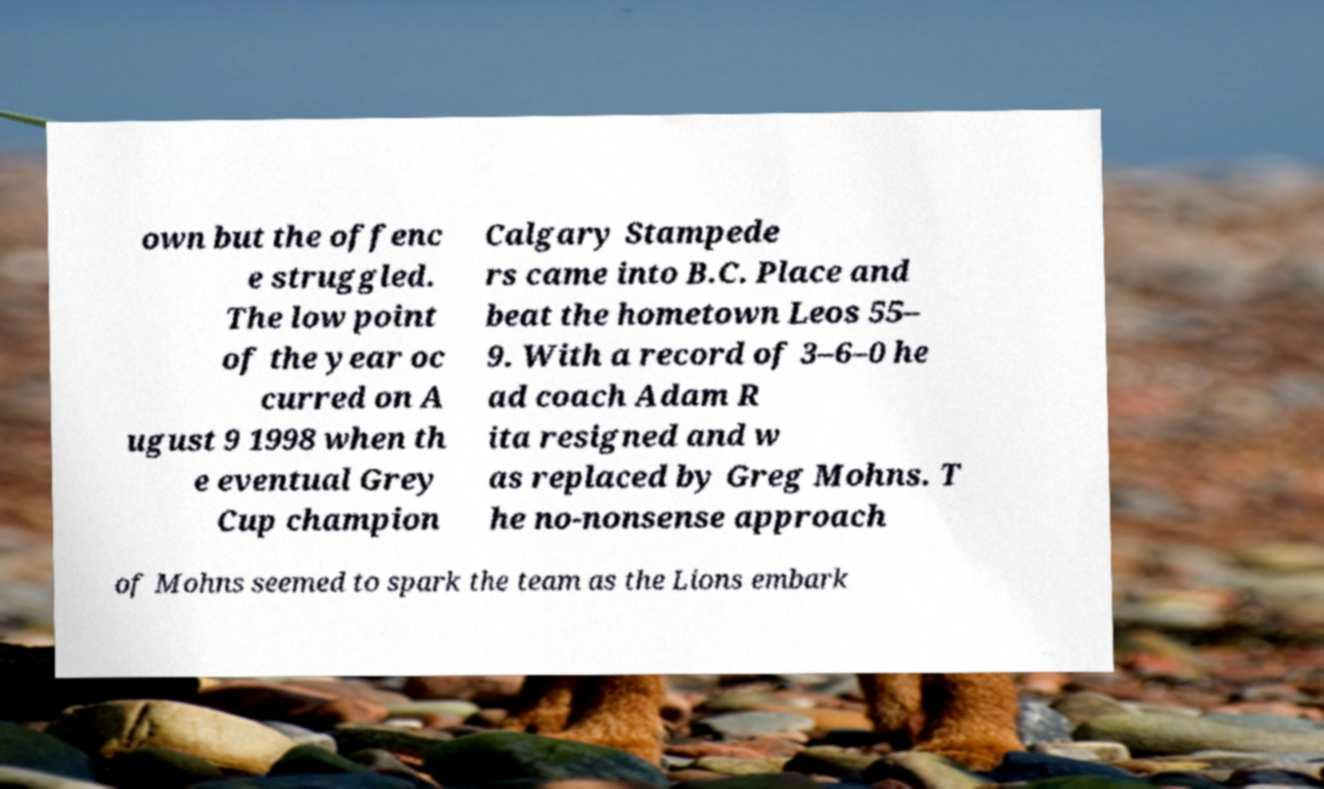Can you read and provide the text displayed in the image?This photo seems to have some interesting text. Can you extract and type it out for me? own but the offenc e struggled. The low point of the year oc curred on A ugust 9 1998 when th e eventual Grey Cup champion Calgary Stampede rs came into B.C. Place and beat the hometown Leos 55– 9. With a record of 3–6–0 he ad coach Adam R ita resigned and w as replaced by Greg Mohns. T he no-nonsense approach of Mohns seemed to spark the team as the Lions embark 